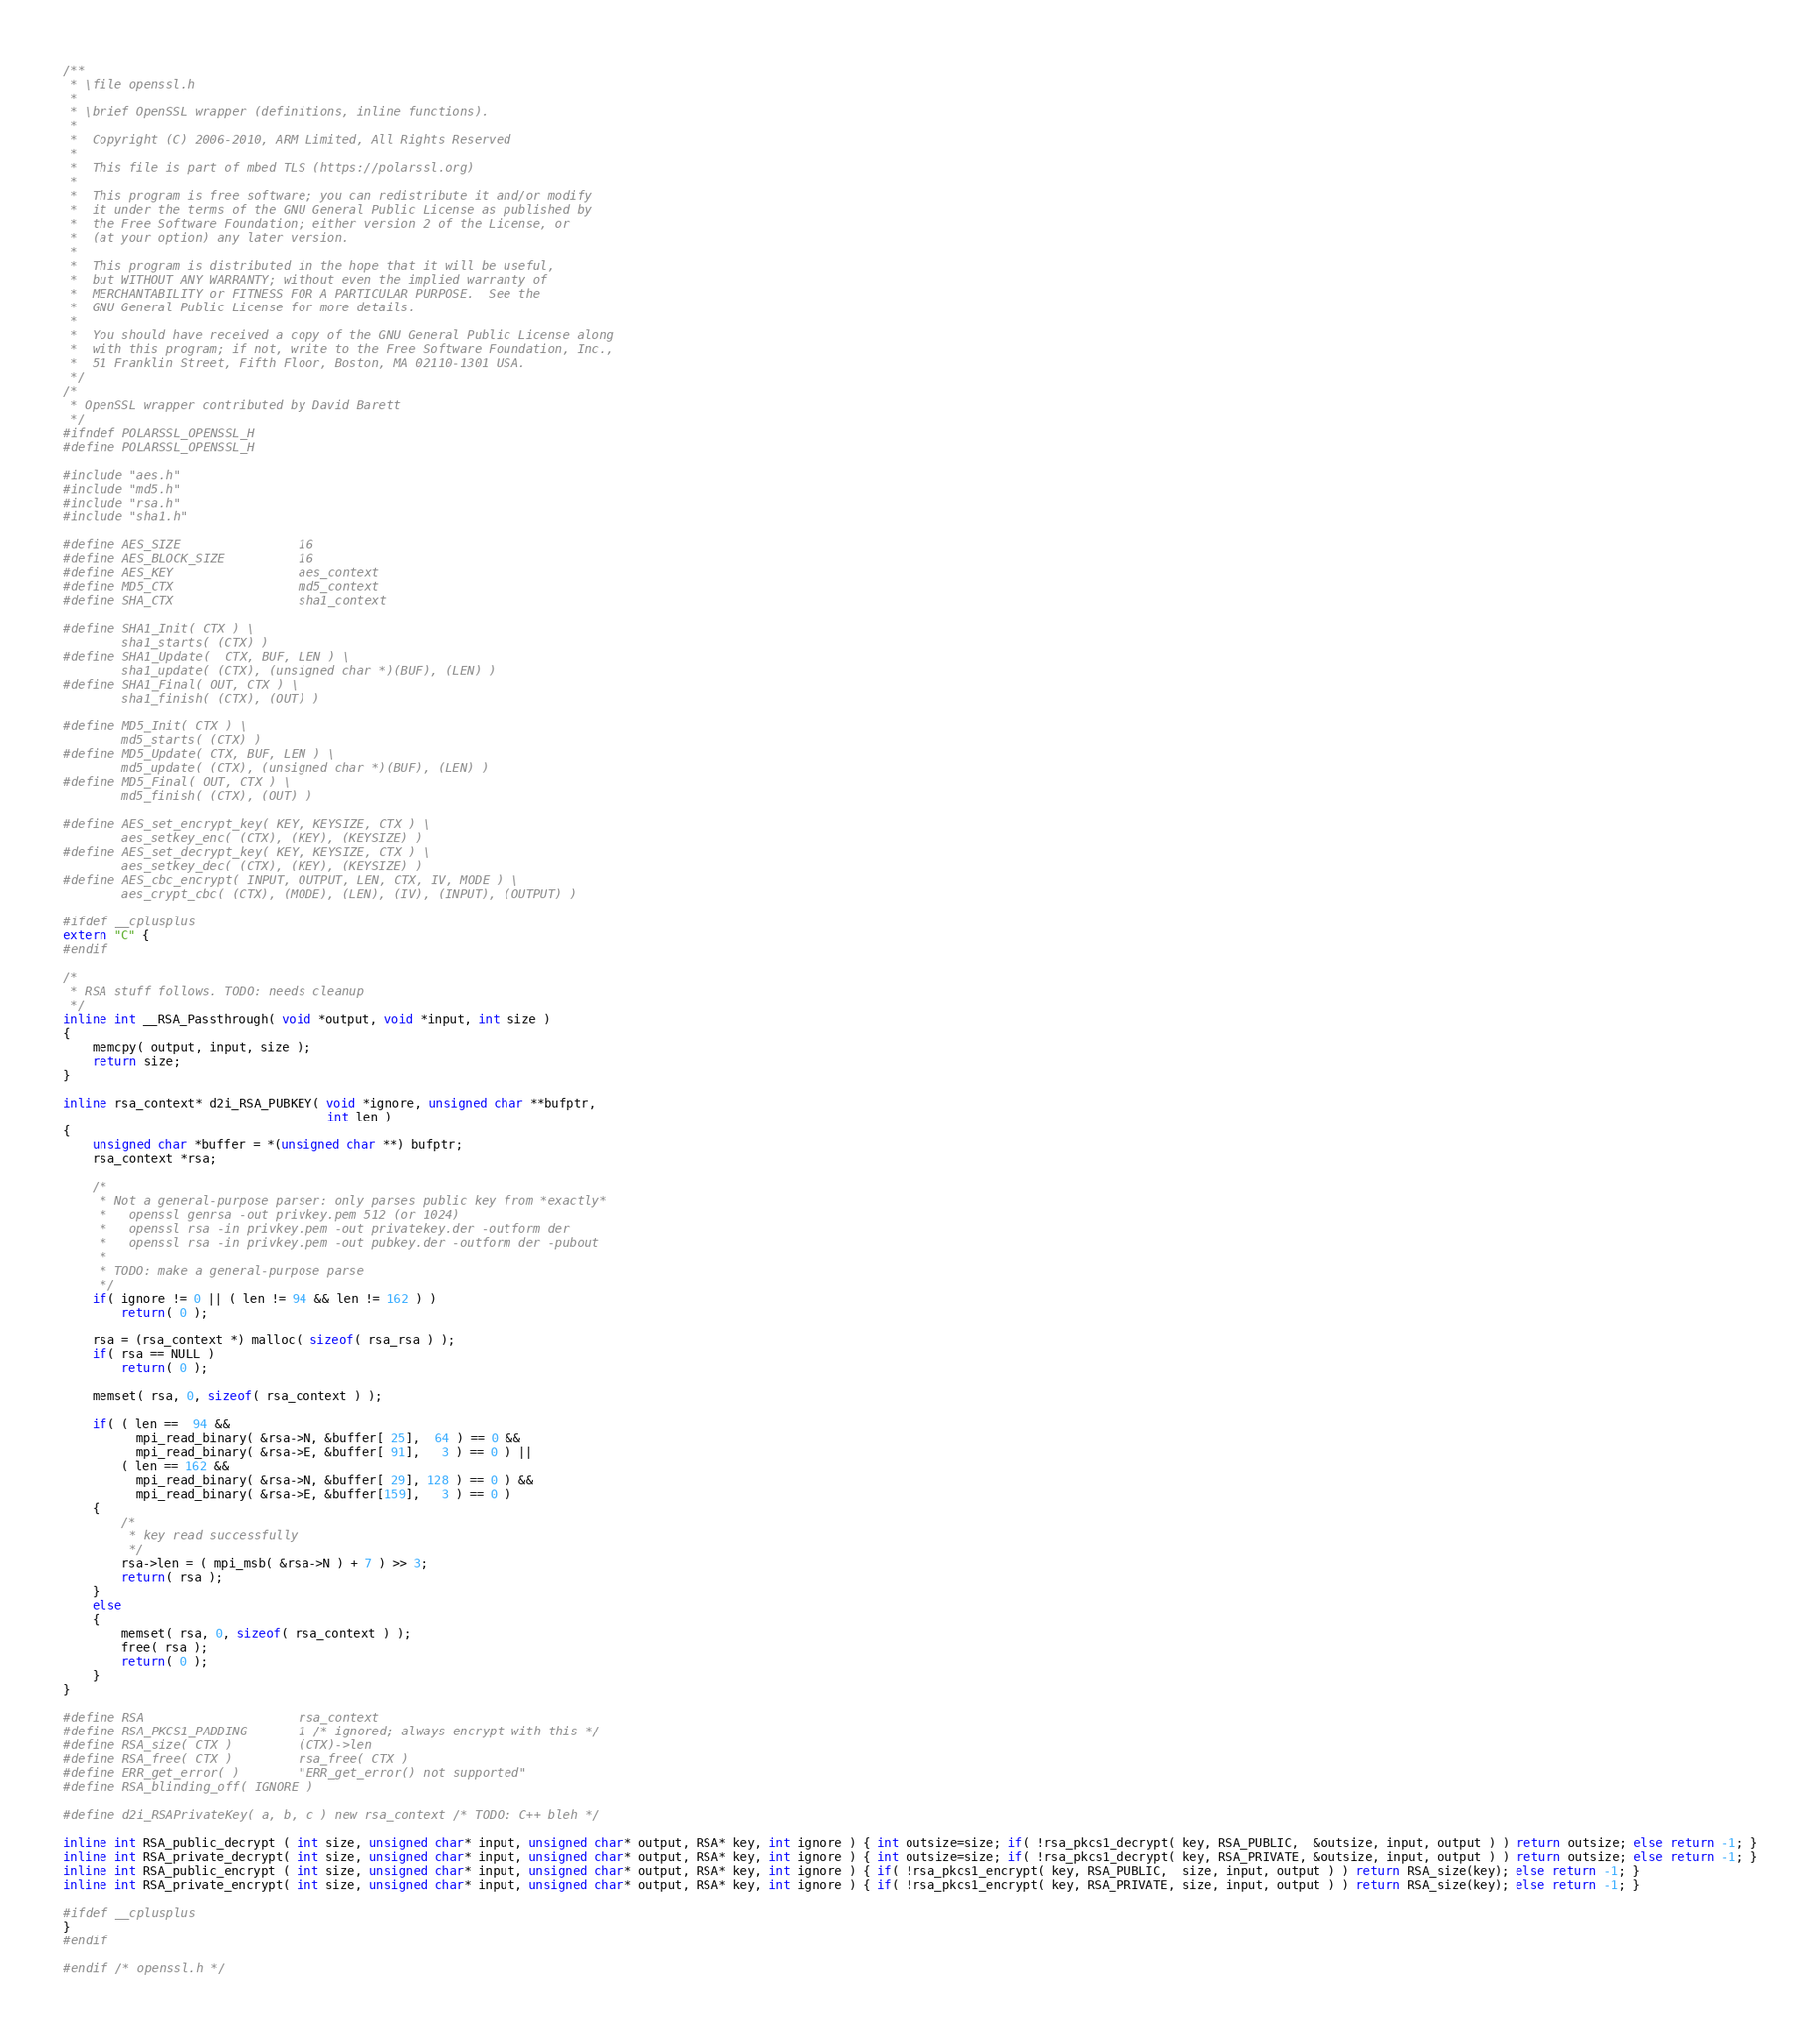<code> <loc_0><loc_0><loc_500><loc_500><_C_>/**
 * \file openssl.h
 *
 * \brief OpenSSL wrapper (definitions, inline functions).
 *
 *  Copyright (C) 2006-2010, ARM Limited, All Rights Reserved
 *
 *  This file is part of mbed TLS (https://polarssl.org)
 *
 *  This program is free software; you can redistribute it and/or modify
 *  it under the terms of the GNU General Public License as published by
 *  the Free Software Foundation; either version 2 of the License, or
 *  (at your option) any later version.
 *
 *  This program is distributed in the hope that it will be useful,
 *  but WITHOUT ANY WARRANTY; without even the implied warranty of
 *  MERCHANTABILITY or FITNESS FOR A PARTICULAR PURPOSE.  See the
 *  GNU General Public License for more details.
 *
 *  You should have received a copy of the GNU General Public License along
 *  with this program; if not, write to the Free Software Foundation, Inc.,
 *  51 Franklin Street, Fifth Floor, Boston, MA 02110-1301 USA.
 */
/*
 * OpenSSL wrapper contributed by David Barett
 */
#ifndef POLARSSL_OPENSSL_H
#define POLARSSL_OPENSSL_H

#include "aes.h"
#include "md5.h"
#include "rsa.h"
#include "sha1.h"

#define AES_SIZE                16
#define AES_BLOCK_SIZE          16
#define AES_KEY                 aes_context
#define MD5_CTX                 md5_context
#define SHA_CTX                 sha1_context

#define SHA1_Init( CTX ) \
        sha1_starts( (CTX) )
#define SHA1_Update(  CTX, BUF, LEN ) \
        sha1_update( (CTX), (unsigned char *)(BUF), (LEN) )
#define SHA1_Final( OUT, CTX ) \
        sha1_finish( (CTX), (OUT) )

#define MD5_Init( CTX ) \
        md5_starts( (CTX) )
#define MD5_Update( CTX, BUF, LEN ) \
        md5_update( (CTX), (unsigned char *)(BUF), (LEN) )
#define MD5_Final( OUT, CTX ) \
        md5_finish( (CTX), (OUT) )

#define AES_set_encrypt_key( KEY, KEYSIZE, CTX ) \
        aes_setkey_enc( (CTX), (KEY), (KEYSIZE) )
#define AES_set_decrypt_key( KEY, KEYSIZE, CTX ) \
        aes_setkey_dec( (CTX), (KEY), (KEYSIZE) )
#define AES_cbc_encrypt( INPUT, OUTPUT, LEN, CTX, IV, MODE ) \
        aes_crypt_cbc( (CTX), (MODE), (LEN), (IV), (INPUT), (OUTPUT) )

#ifdef __cplusplus
extern "C" {
#endif

/*
 * RSA stuff follows. TODO: needs cleanup
 */
inline int __RSA_Passthrough( void *output, void *input, int size )
{
    memcpy( output, input, size );
    return size;
}

inline rsa_context* d2i_RSA_PUBKEY( void *ignore, unsigned char **bufptr,
                                    int len )
{
    unsigned char *buffer = *(unsigned char **) bufptr;
    rsa_context *rsa;

    /*
     * Not a general-purpose parser: only parses public key from *exactly*
     *   openssl genrsa -out privkey.pem 512 (or 1024)
     *   openssl rsa -in privkey.pem -out privatekey.der -outform der
     *   openssl rsa -in privkey.pem -out pubkey.der -outform der -pubout
     *
     * TODO: make a general-purpose parse
     */
    if( ignore != 0 || ( len != 94 && len != 162 ) )
        return( 0 );

    rsa = (rsa_context *) malloc( sizeof( rsa_rsa ) );
    if( rsa == NULL )
        return( 0 );

    memset( rsa, 0, sizeof( rsa_context ) );

    if( ( len ==  94 &&
          mpi_read_binary( &rsa->N, &buffer[ 25],  64 ) == 0 &&
          mpi_read_binary( &rsa->E, &buffer[ 91],   3 ) == 0 ) ||
        ( len == 162 &&
          mpi_read_binary( &rsa->N, &buffer[ 29], 128 ) == 0 ) &&
          mpi_read_binary( &rsa->E, &buffer[159],   3 ) == 0 )
    {
        /*
         * key read successfully
         */
        rsa->len = ( mpi_msb( &rsa->N ) + 7 ) >> 3;
        return( rsa );
    }
    else
    {
        memset( rsa, 0, sizeof( rsa_context ) );
        free( rsa );
        return( 0 );
    }
}

#define RSA                     rsa_context
#define RSA_PKCS1_PADDING       1 /* ignored; always encrypt with this */
#define RSA_size( CTX )         (CTX)->len
#define RSA_free( CTX )         rsa_free( CTX )
#define ERR_get_error( )        "ERR_get_error() not supported"
#define RSA_blinding_off( IGNORE )

#define d2i_RSAPrivateKey( a, b, c ) new rsa_context /* TODO: C++ bleh */

inline int RSA_public_decrypt ( int size, unsigned char* input, unsigned char* output, RSA* key, int ignore ) { int outsize=size; if( !rsa_pkcs1_decrypt( key, RSA_PUBLIC,  &outsize, input, output ) ) return outsize; else return -1; }
inline int RSA_private_decrypt( int size, unsigned char* input, unsigned char* output, RSA* key, int ignore ) { int outsize=size; if( !rsa_pkcs1_decrypt( key, RSA_PRIVATE, &outsize, input, output ) ) return outsize; else return -1; }
inline int RSA_public_encrypt ( int size, unsigned char* input, unsigned char* output, RSA* key, int ignore ) { if( !rsa_pkcs1_encrypt( key, RSA_PUBLIC,  size, input, output ) ) return RSA_size(key); else return -1; }
inline int RSA_private_encrypt( int size, unsigned char* input, unsigned char* output, RSA* key, int ignore ) { if( !rsa_pkcs1_encrypt( key, RSA_PRIVATE, size, input, output ) ) return RSA_size(key); else return -1; }

#ifdef __cplusplus
}
#endif

#endif /* openssl.h */
</code> 